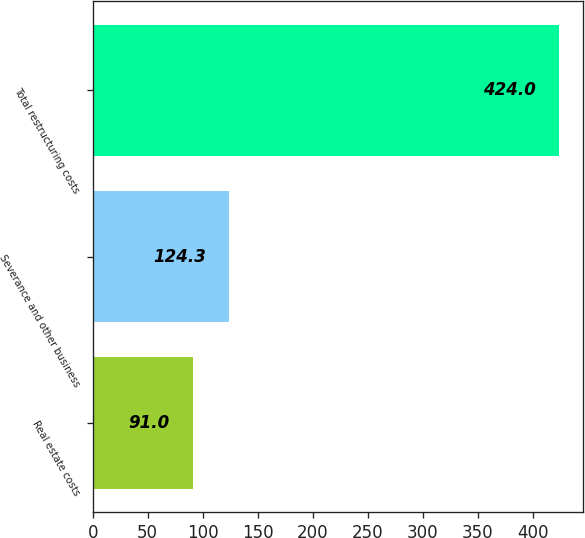<chart> <loc_0><loc_0><loc_500><loc_500><bar_chart><fcel>Real estate costs<fcel>Severance and other business<fcel>Total restructuring costs<nl><fcel>91<fcel>124.3<fcel>424<nl></chart> 